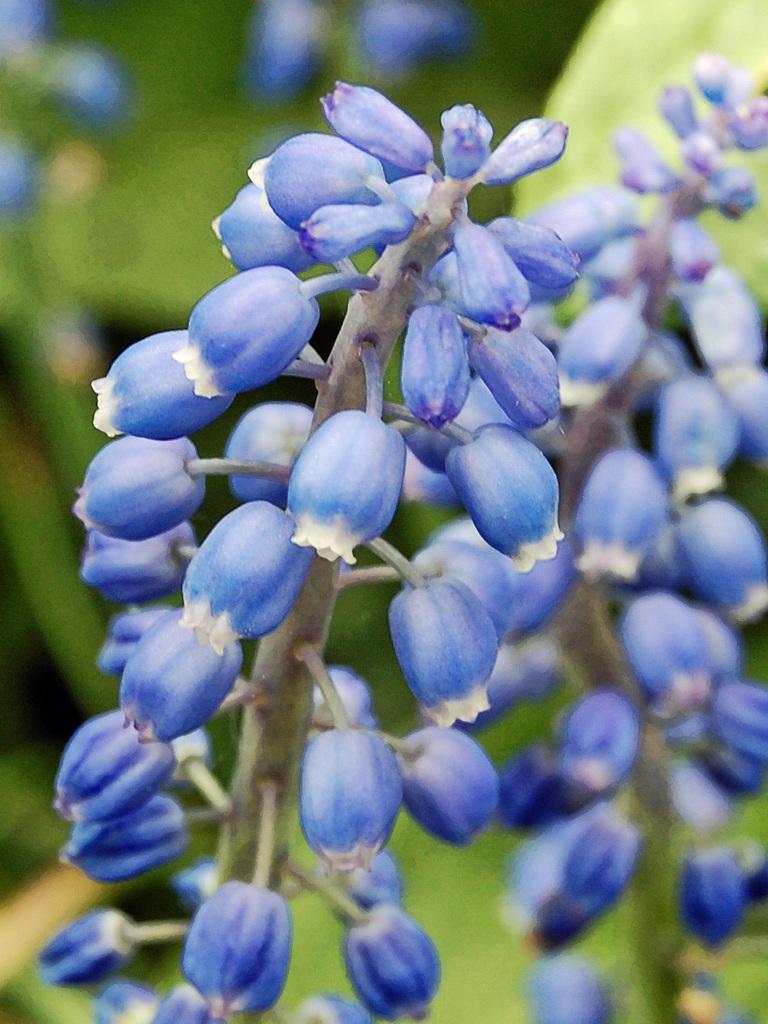How would you summarize this image in a sentence or two? In this image we can see fruits. 